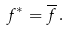<formula> <loc_0><loc_0><loc_500><loc_500>f ^ { * } = \overline { f } \, .</formula> 